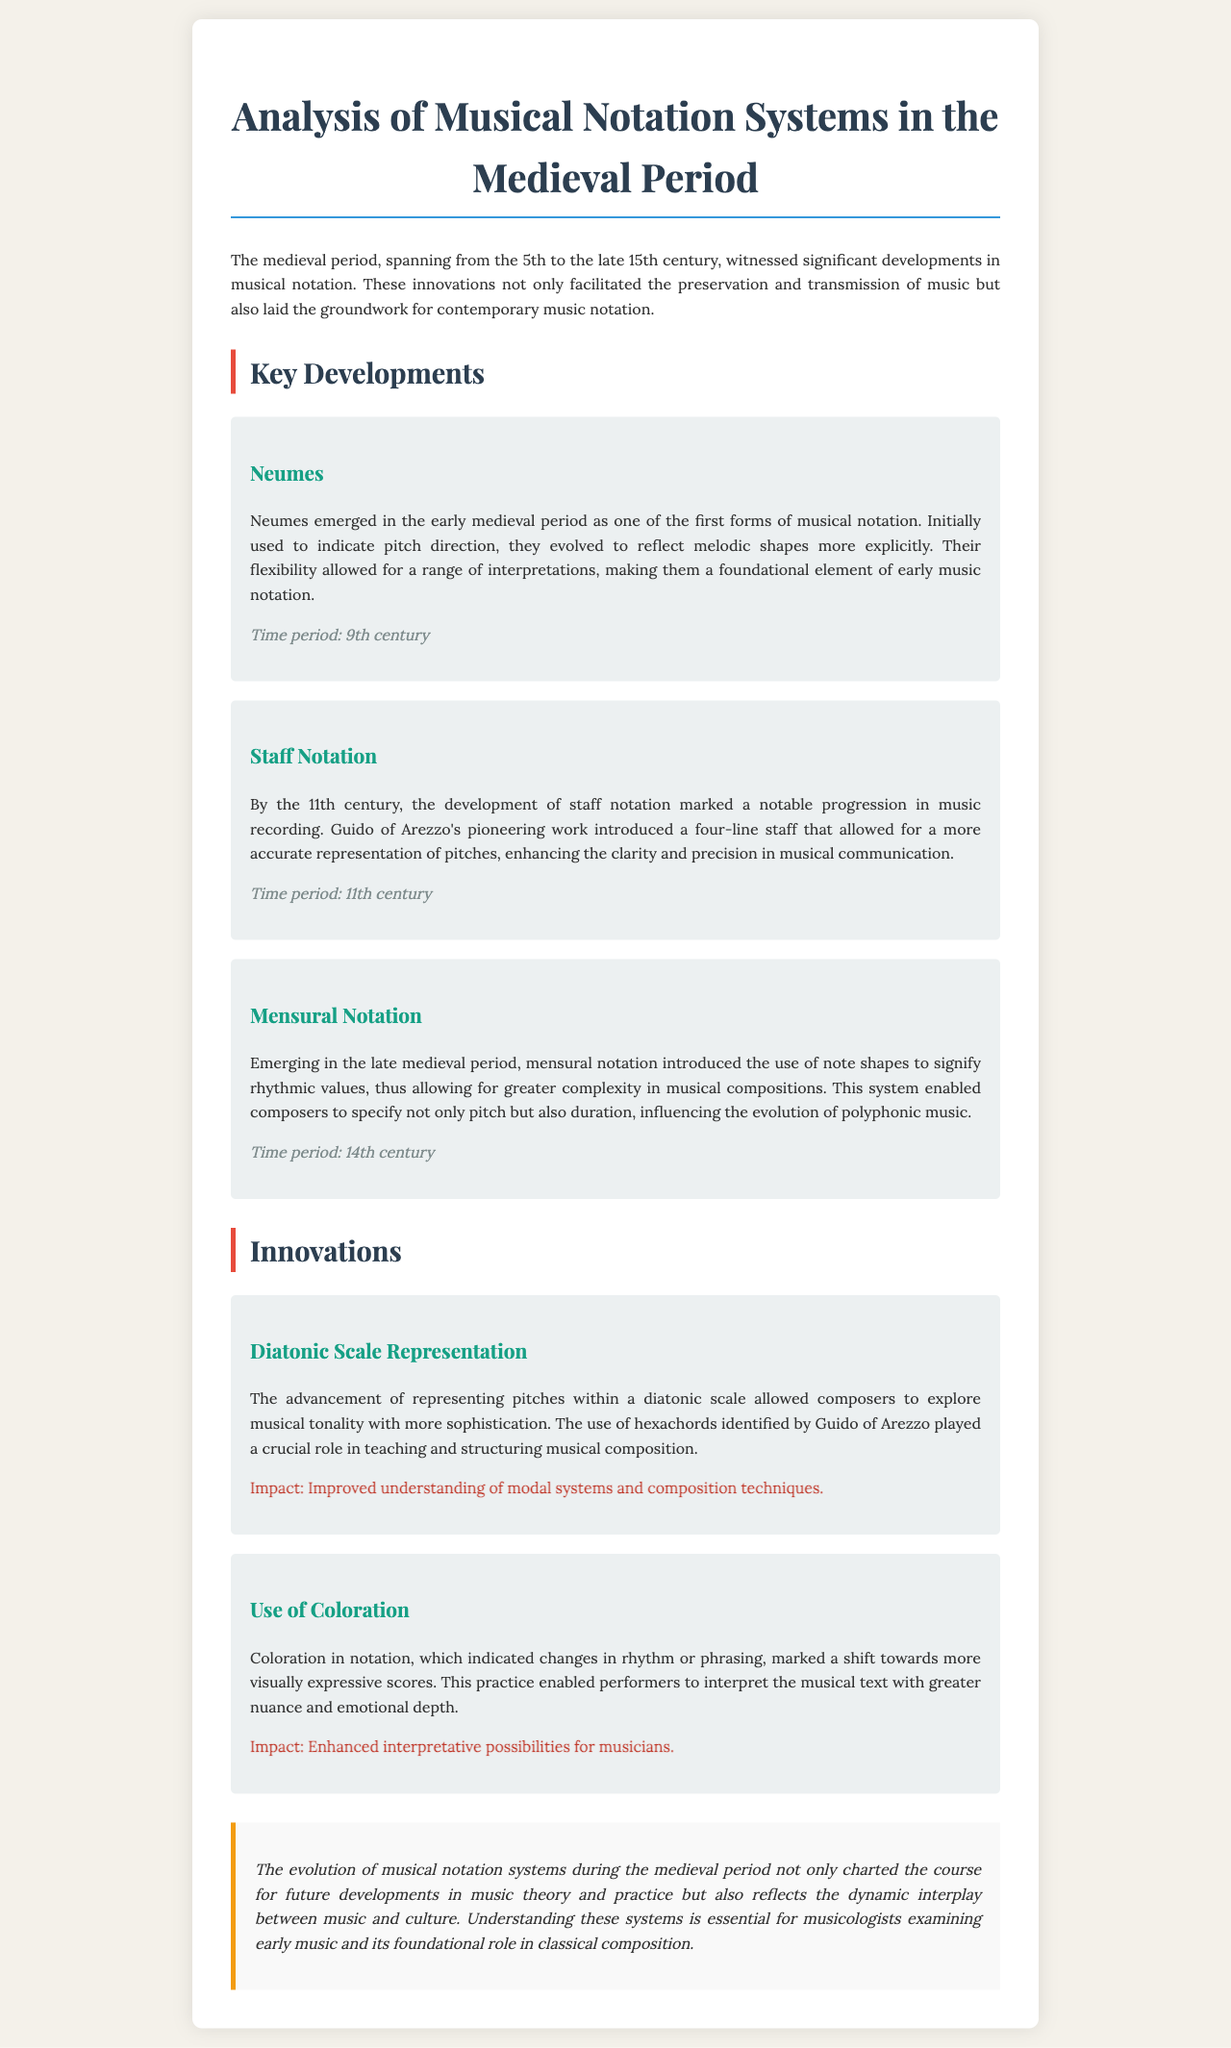What are neumes? Neumes are one of the first forms of musical notation that emerged in the early medieval period.
Answer: One of the first forms of musical notation When did staff notation develop? Staff notation marked a notable progression in music recording by the 11th century.
Answer: 11th century What did Guido of Arezzo introduce? Guido of Arezzo introduced a four-line staff for more accurate representation of pitches.
Answer: A four-line staff What is mensural notation? Mensural notation introduced the use of note shapes to signify rhythmic values and allowed for greater complexity.
Answer: A system for rhythmic values What impact did diatonic scale representation have? The impact was improved understanding of modal systems and composition techniques.
Answer: Improved understanding of modal systems What does coloration in notation indicate? Coloration indicated changes in rhythm or phrasing in musical scores.
Answer: Changes in rhythm or phrasing What time period are neumes associated with? Neumes are associated with the 9th century.
Answer: 9th century What did the development of staff notation enhance? It enhanced the clarity and precision in musical communication.
Answer: Clarity and precision in musical communication What role did hexachords play according to Guido of Arezzo? Hexachords played a crucial role in teaching and structuring musical composition.
Answer: Teaching and structuring musical composition 